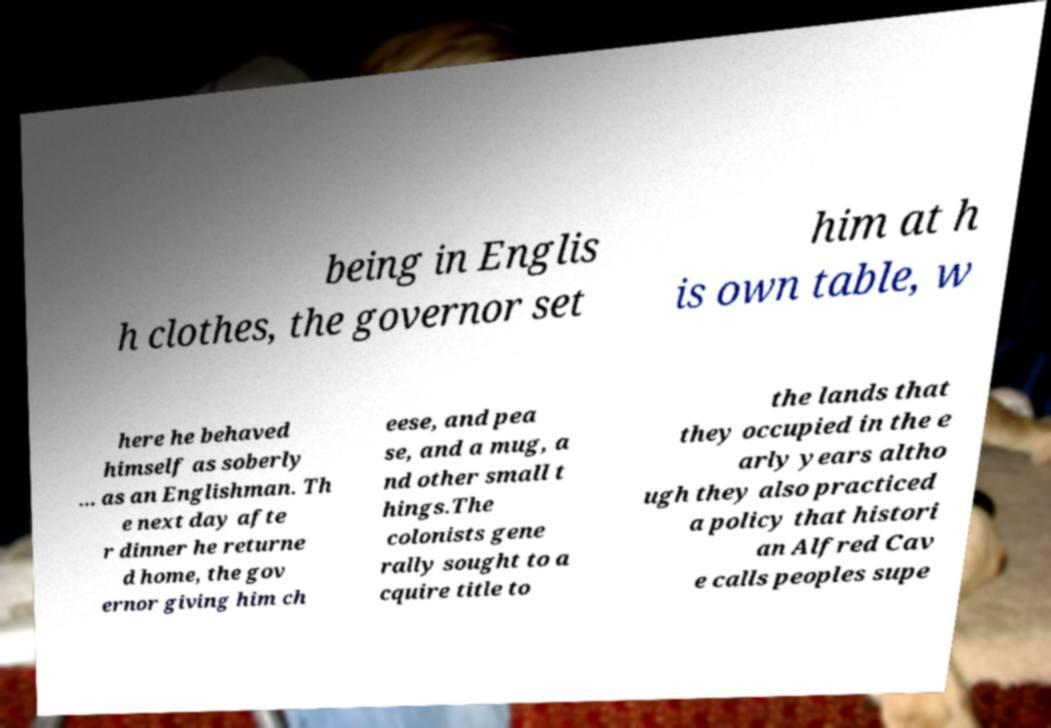Please identify and transcribe the text found in this image. being in Englis h clothes, the governor set him at h is own table, w here he behaved himself as soberly ... as an Englishman. Th e next day afte r dinner he returne d home, the gov ernor giving him ch eese, and pea se, and a mug, a nd other small t hings.The colonists gene rally sought to a cquire title to the lands that they occupied in the e arly years altho ugh they also practiced a policy that histori an Alfred Cav e calls peoples supe 